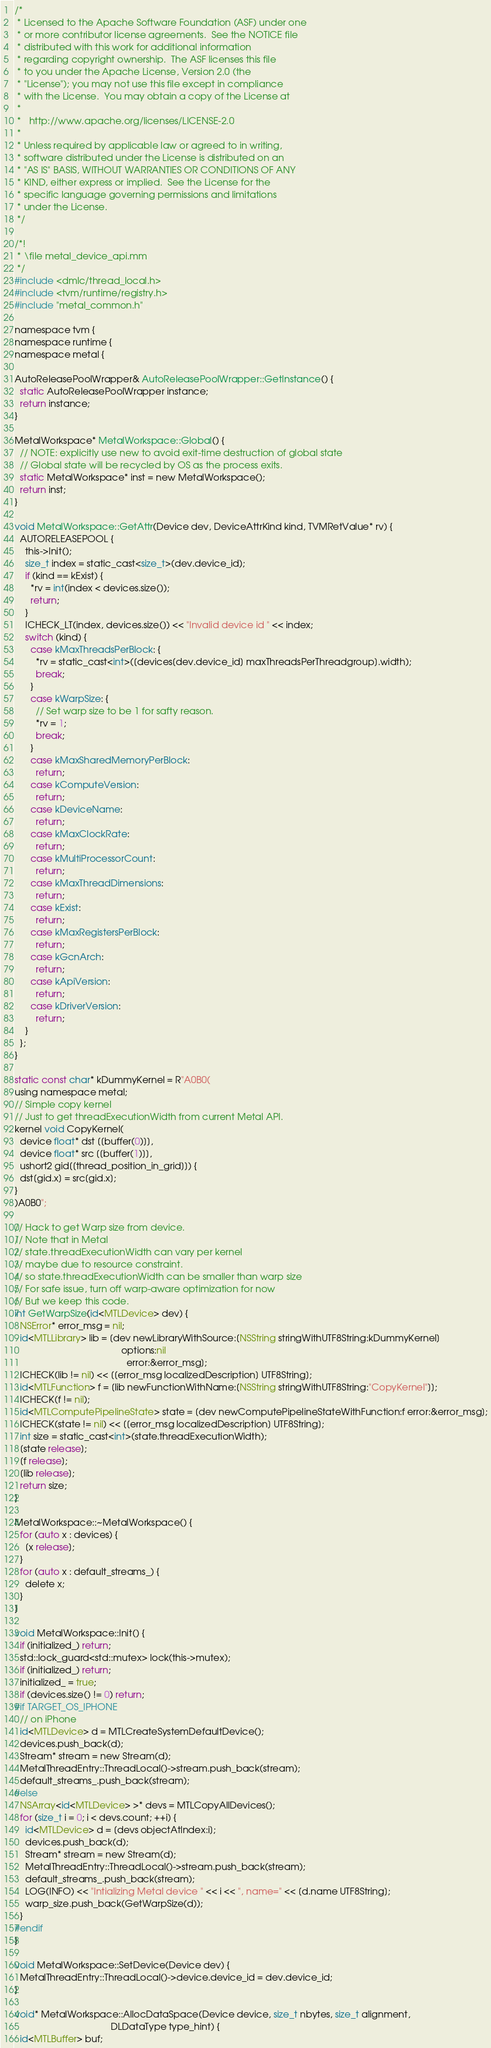<code> <loc_0><loc_0><loc_500><loc_500><_ObjectiveC_>
/*
 * Licensed to the Apache Software Foundation (ASF) under one
 * or more contributor license agreements.  See the NOTICE file
 * distributed with this work for additional information
 * regarding copyright ownership.  The ASF licenses this file
 * to you under the Apache License, Version 2.0 (the
 * "License"); you may not use this file except in compliance
 * with the License.  You may obtain a copy of the License at
 *
 *   http://www.apache.org/licenses/LICENSE-2.0
 *
 * Unless required by applicable law or agreed to in writing,
 * software distributed under the License is distributed on an
 * "AS IS" BASIS, WITHOUT WARRANTIES OR CONDITIONS OF ANY
 * KIND, either express or implied.  See the License for the
 * specific language governing permissions and limitations
 * under the License.
 */

/*!
 * \file metal_device_api.mm
 */
#include <dmlc/thread_local.h>
#include <tvm/runtime/registry.h>
#include "metal_common.h"

namespace tvm {
namespace runtime {
namespace metal {

AutoReleasePoolWrapper& AutoReleasePoolWrapper::GetInstance() {
  static AutoReleasePoolWrapper instance;
  return instance;
}

MetalWorkspace* MetalWorkspace::Global() {
  // NOTE: explicitly use new to avoid exit-time destruction of global state
  // Global state will be recycled by OS as the process exits.
  static MetalWorkspace* inst = new MetalWorkspace();
  return inst;
}

void MetalWorkspace::GetAttr(Device dev, DeviceAttrKind kind, TVMRetValue* rv) {
  AUTORELEASEPOOL {
    this->Init();
    size_t index = static_cast<size_t>(dev.device_id);
    if (kind == kExist) {
      *rv = int(index < devices.size());
      return;
    }
    ICHECK_LT(index, devices.size()) << "Invalid device id " << index;
    switch (kind) {
      case kMaxThreadsPerBlock: {
        *rv = static_cast<int>([devices[dev.device_id] maxThreadsPerThreadgroup].width);
        break;
      }
      case kWarpSize: {
        // Set warp size to be 1 for safty reason.
        *rv = 1;
        break;
      }
      case kMaxSharedMemoryPerBlock:
        return;
      case kComputeVersion:
        return;
      case kDeviceName:
        return;
      case kMaxClockRate:
        return;
      case kMultiProcessorCount:
        return;
      case kMaxThreadDimensions:
        return;
      case kExist:
        return;
      case kMaxRegistersPerBlock:
        return;
      case kGcnArch:
        return;
      case kApiVersion:
        return;
      case kDriverVersion:
        return;
    }
  };
}

static const char* kDummyKernel = R"A0B0(
using namespace metal;
// Simple copy kernel
// Just to get threadExecutionWidth from current Metal API.
kernel void CopyKernel(
  device float* dst [[buffer(0)]],
  device float* src [[buffer(1)]],
  ushort2 gid[[thread_position_in_grid]]) {
  dst[gid.x] = src[gid.x];
}
)A0B0";

// Hack to get Warp size from device.
// Note that in Metal
// state.threadExecutionWidth can vary per kernel
// maybe due to resource constraint.
// so state.threadExecutionWidth can be smaller than warp size
// For safe issue, turn off warp-aware optimization for now
// But we keep this code.
int GetWarpSize(id<MTLDevice> dev) {
  NSError* error_msg = nil;
  id<MTLLibrary> lib = [dev newLibraryWithSource:[NSString stringWithUTF8String:kDummyKernel]
                                         options:nil
                                           error:&error_msg];
  ICHECK(lib != nil) << [[error_msg localizedDescription] UTF8String];
  id<MTLFunction> f = [lib newFunctionWithName:[NSString stringWithUTF8String:"CopyKernel"]];
  ICHECK(f != nil);
  id<MTLComputePipelineState> state = [dev newComputePipelineStateWithFunction:f error:&error_msg];
  ICHECK(state != nil) << [[error_msg localizedDescription] UTF8String];
  int size = static_cast<int>(state.threadExecutionWidth);
  [state release];
  [f release];
  [lib release];
  return size;
}

MetalWorkspace::~MetalWorkspace() {
  for (auto x : devices) {
    [x release];
  }
  for (auto x : default_streams_) {
    delete x;
  }
}

void MetalWorkspace::Init() {
  if (initialized_) return;
  std::lock_guard<std::mutex> lock(this->mutex);
  if (initialized_) return;
  initialized_ = true;
  if (devices.size() != 0) return;
#if TARGET_OS_IPHONE
  // on iPhone
  id<MTLDevice> d = MTLCreateSystemDefaultDevice();
  devices.push_back(d);
  Stream* stream = new Stream(d);
  MetalThreadEntry::ThreadLocal()->stream.push_back(stream);
  default_streams_.push_back(stream);
#else
  NSArray<id<MTLDevice> >* devs = MTLCopyAllDevices();
  for (size_t i = 0; i < devs.count; ++i) {
    id<MTLDevice> d = [devs objectAtIndex:i];
    devices.push_back(d);
    Stream* stream = new Stream(d);
    MetalThreadEntry::ThreadLocal()->stream.push_back(stream);
    default_streams_.push_back(stream);
    LOG(INFO) << "Intializing Metal device " << i << ", name=" << [d.name UTF8String];
    warp_size.push_back(GetWarpSize(d));
  }
#endif
}

void MetalWorkspace::SetDevice(Device dev) {
  MetalThreadEntry::ThreadLocal()->device.device_id = dev.device_id;
}

void* MetalWorkspace::AllocDataSpace(Device device, size_t nbytes, size_t alignment,
                                     DLDataType type_hint) {
  id<MTLBuffer> buf;</code> 